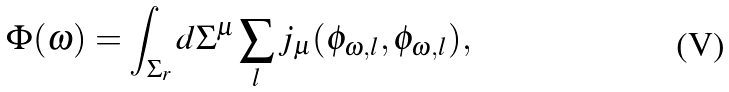Convert formula to latex. <formula><loc_0><loc_0><loc_500><loc_500>\Phi ( \omega ) = \int _ { \Sigma _ { r } } d \Sigma ^ { \mu } \sum _ { l } j _ { \mu } ( \phi _ { \omega , l } , \phi _ { \omega , l } ) ,</formula> 